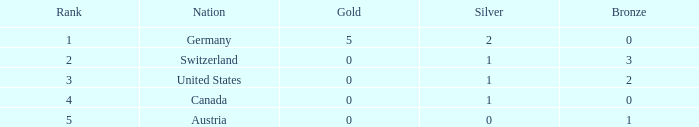What is the total number of bronze when the total is less than 1? None. 